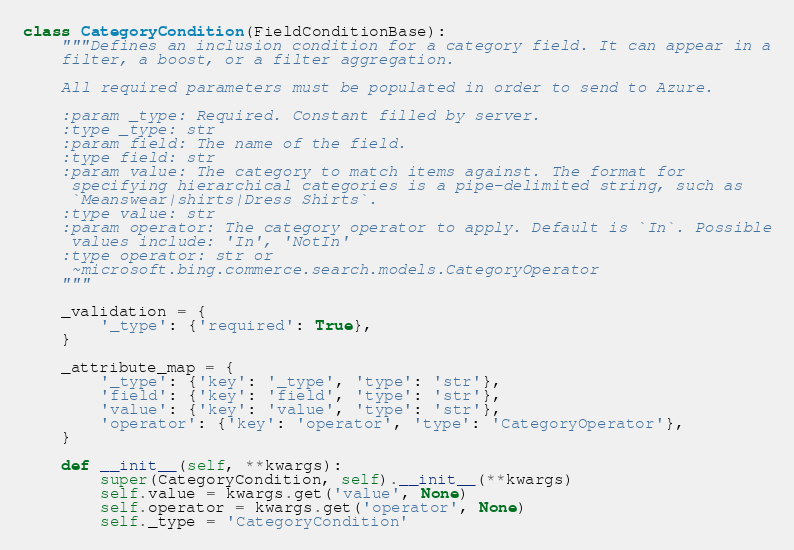<code> <loc_0><loc_0><loc_500><loc_500><_Python_>class CategoryCondition(FieldConditionBase):
    """Defines an inclusion condition for a category field. It can appear in a
    filter, a boost, or a filter aggregation.

    All required parameters must be populated in order to send to Azure.

    :param _type: Required. Constant filled by server.
    :type _type: str
    :param field: The name of the field.
    :type field: str
    :param value: The category to match items against. The format for
     specifying hierarchical categories is a pipe-delimited string, such as
     `Meanswear|shirts|Dress Shirts`.
    :type value: str
    :param operator: The category operator to apply. Default is `In`. Possible
     values include: 'In', 'NotIn'
    :type operator: str or
     ~microsoft.bing.commerce.search.models.CategoryOperator
    """

    _validation = {
        '_type': {'required': True},
    }

    _attribute_map = {
        '_type': {'key': '_type', 'type': 'str'},
        'field': {'key': 'field', 'type': 'str'},
        'value': {'key': 'value', 'type': 'str'},
        'operator': {'key': 'operator', 'type': 'CategoryOperator'},
    }

    def __init__(self, **kwargs):
        super(CategoryCondition, self).__init__(**kwargs)
        self.value = kwargs.get('value', None)
        self.operator = kwargs.get('operator', None)
        self._type = 'CategoryCondition'
</code> 